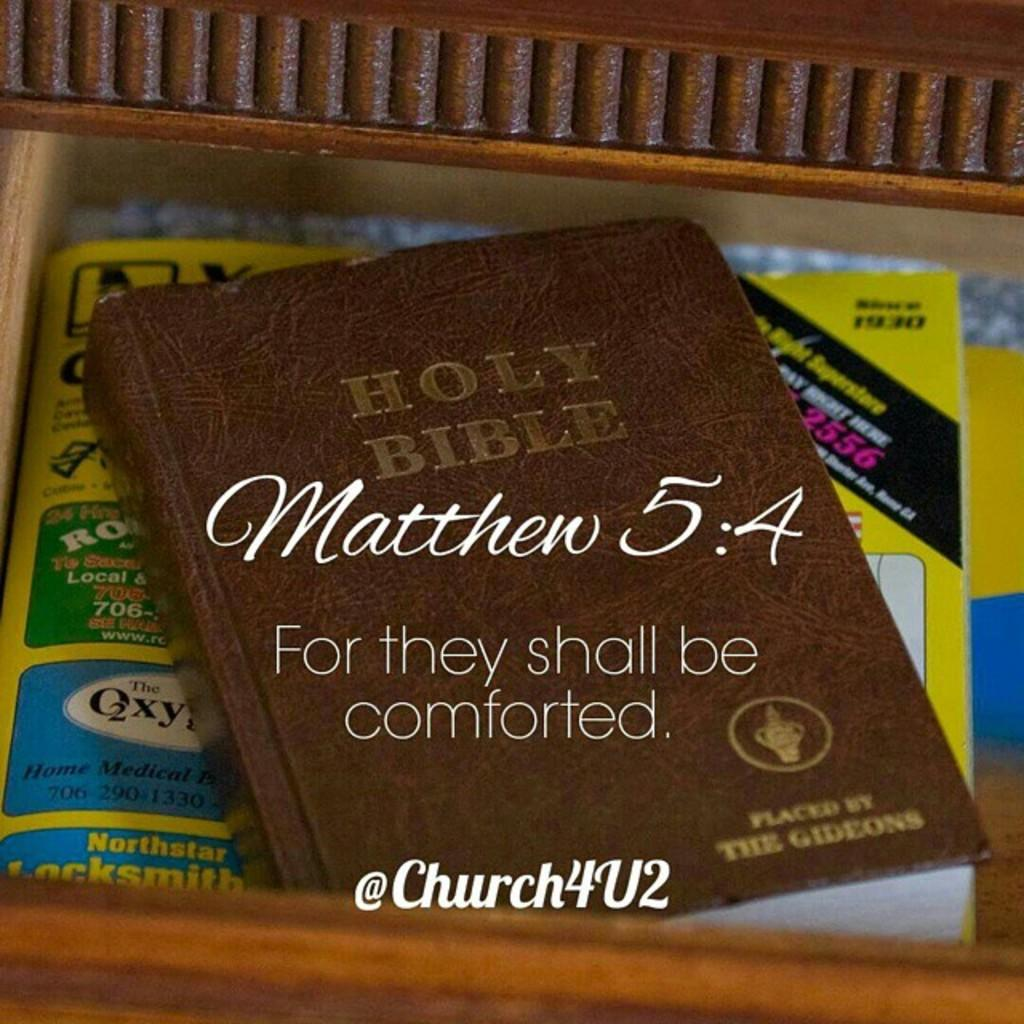<image>
Relay a brief, clear account of the picture shown. Brown Holy Bible with a phrase from Matthew 5:4 on the front. 